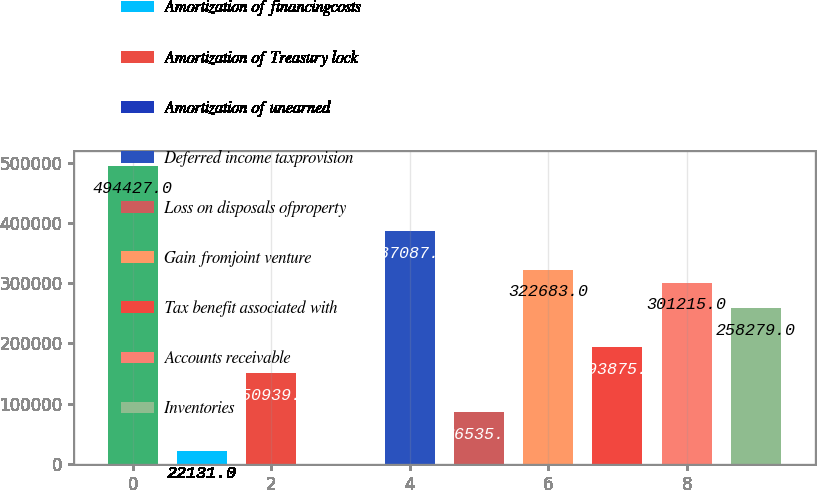Convert chart to OTSL. <chart><loc_0><loc_0><loc_500><loc_500><bar_chart><fcel>Depreciation depletion and<fcel>Amortization of financingcosts<fcel>Amortization of Treasury lock<fcel>Amortization of unearned<fcel>Deferred income taxprovision<fcel>Loss on disposals ofproperty<fcel>Gain fromjoint venture<fcel>Tax benefit associated with<fcel>Accounts receivable<fcel>Inventories<nl><fcel>494427<fcel>22131<fcel>150939<fcel>663<fcel>387087<fcel>86535<fcel>322683<fcel>193875<fcel>301215<fcel>258279<nl></chart> 